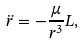<formula> <loc_0><loc_0><loc_500><loc_500>\ddot { r } = - \frac { \mu } { r ^ { 3 } } L ,</formula> 